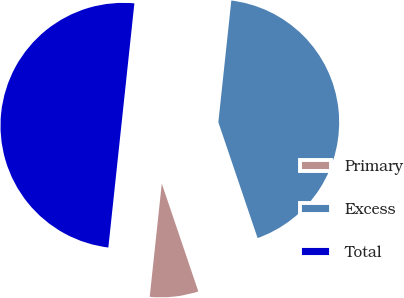Convert chart to OTSL. <chart><loc_0><loc_0><loc_500><loc_500><pie_chart><fcel>Primary<fcel>Excess<fcel>Total<nl><fcel>6.89%<fcel>43.11%<fcel>50.0%<nl></chart> 